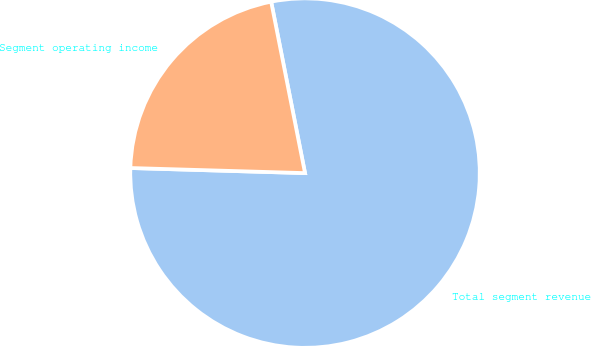Convert chart. <chart><loc_0><loc_0><loc_500><loc_500><pie_chart><fcel>Total segment revenue<fcel>Segment operating income<nl><fcel>78.57%<fcel>21.43%<nl></chart> 